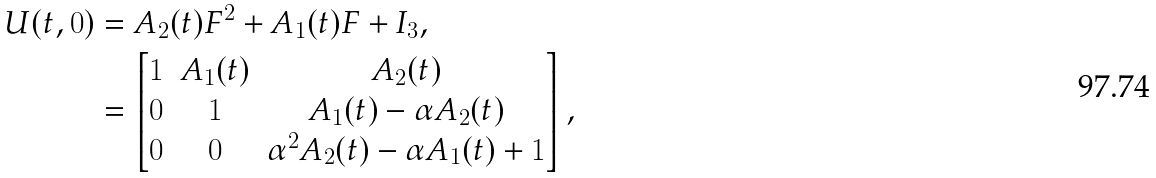Convert formula to latex. <formula><loc_0><loc_0><loc_500><loc_500>U ( t , 0 ) & = A _ { 2 } ( t ) F ^ { 2 } + A _ { 1 } ( t ) F + I _ { 3 } , \\ & = \begin{bmatrix} 1 & A _ { 1 } ( t ) & A _ { 2 } ( t ) \\ 0 & 1 & A _ { 1 } ( t ) - \alpha A _ { 2 } ( t ) \\ 0 & 0 & \alpha ^ { 2 } A _ { 2 } ( t ) - \alpha A _ { 1 } ( t ) + 1 \end{bmatrix} ,</formula> 